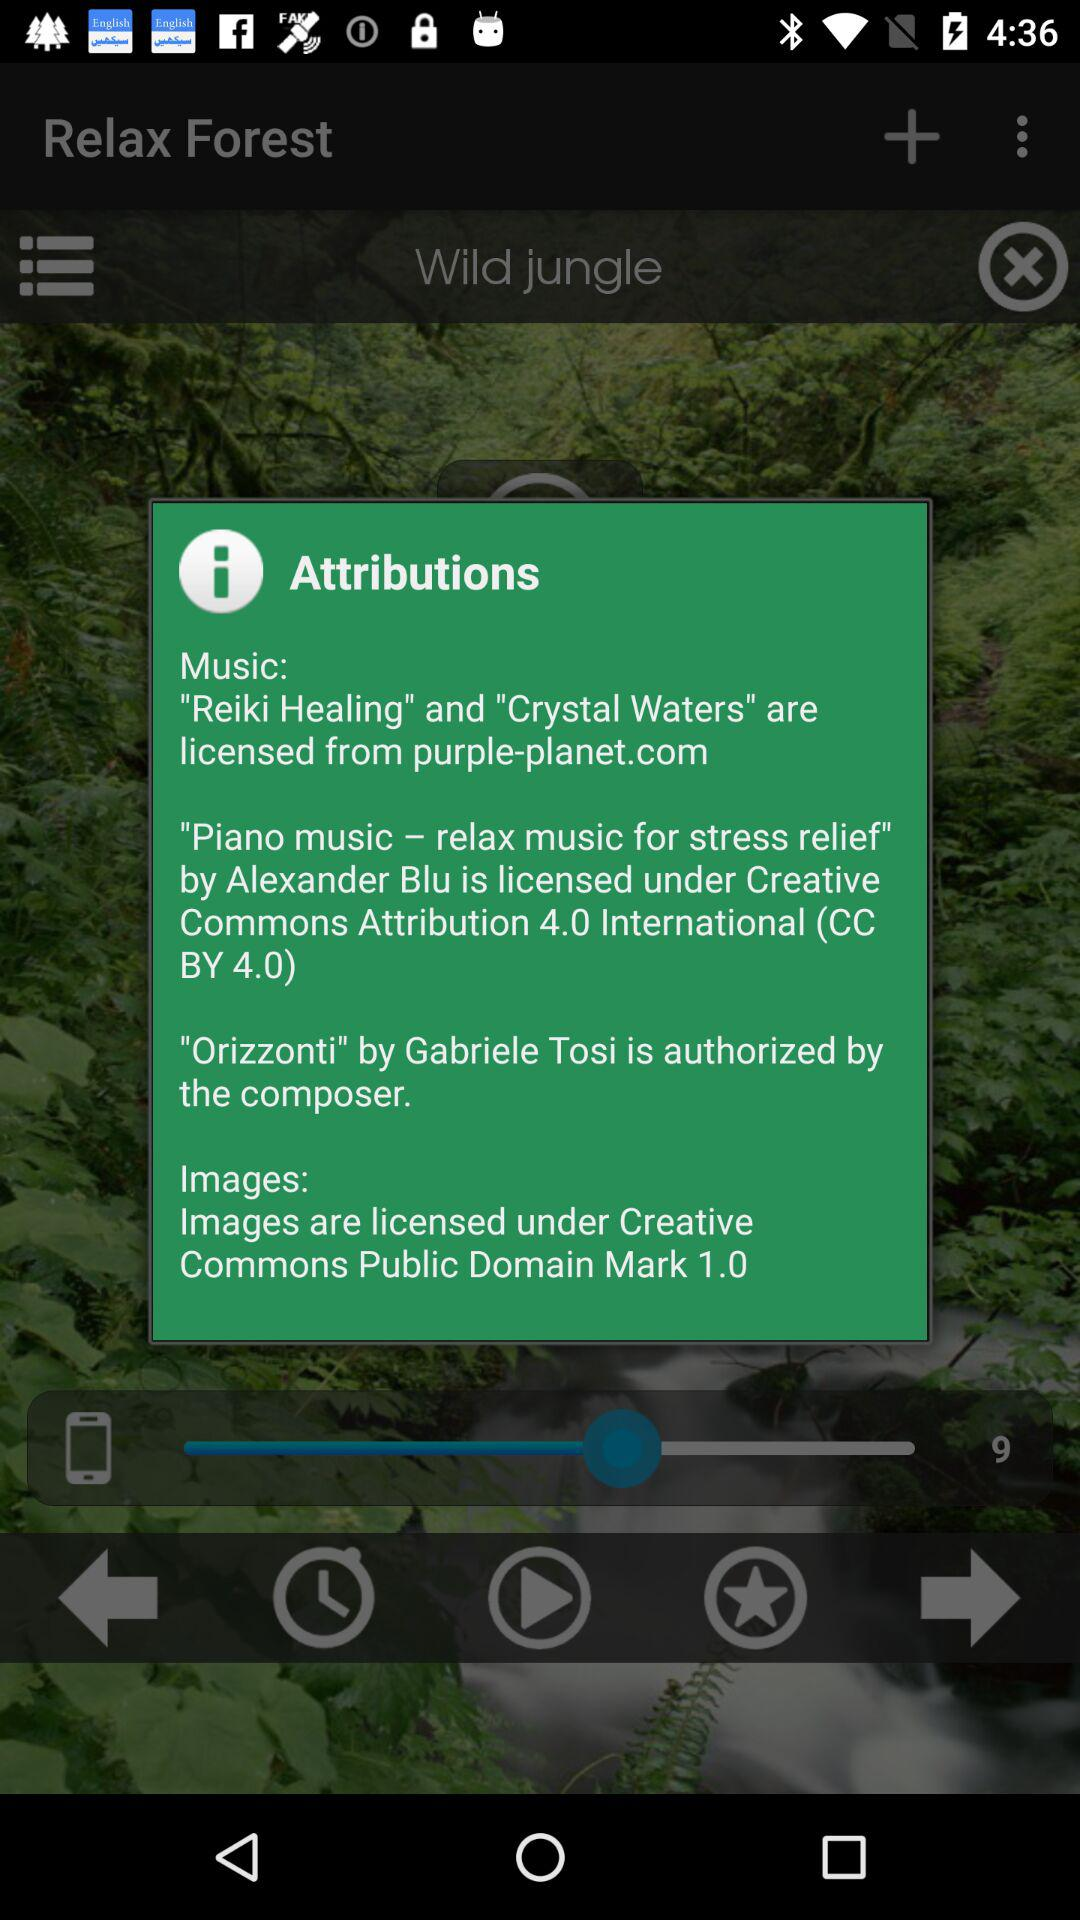Which music is licensed under "Creative Commons Attribution 4.0 International"? The music that is licensed under "Creative Commons Attribution 4.0 International" is "Piano music relax music for stress relief". 